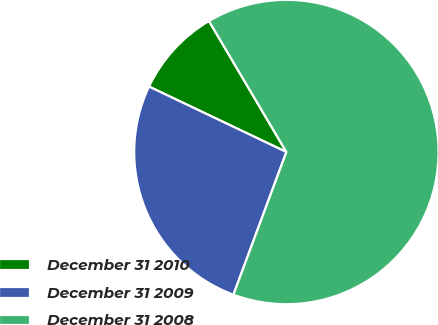Convert chart to OTSL. <chart><loc_0><loc_0><loc_500><loc_500><pie_chart><fcel>December 31 2010<fcel>December 31 2009<fcel>December 31 2008<nl><fcel>9.43%<fcel>26.42%<fcel>64.15%<nl></chart> 